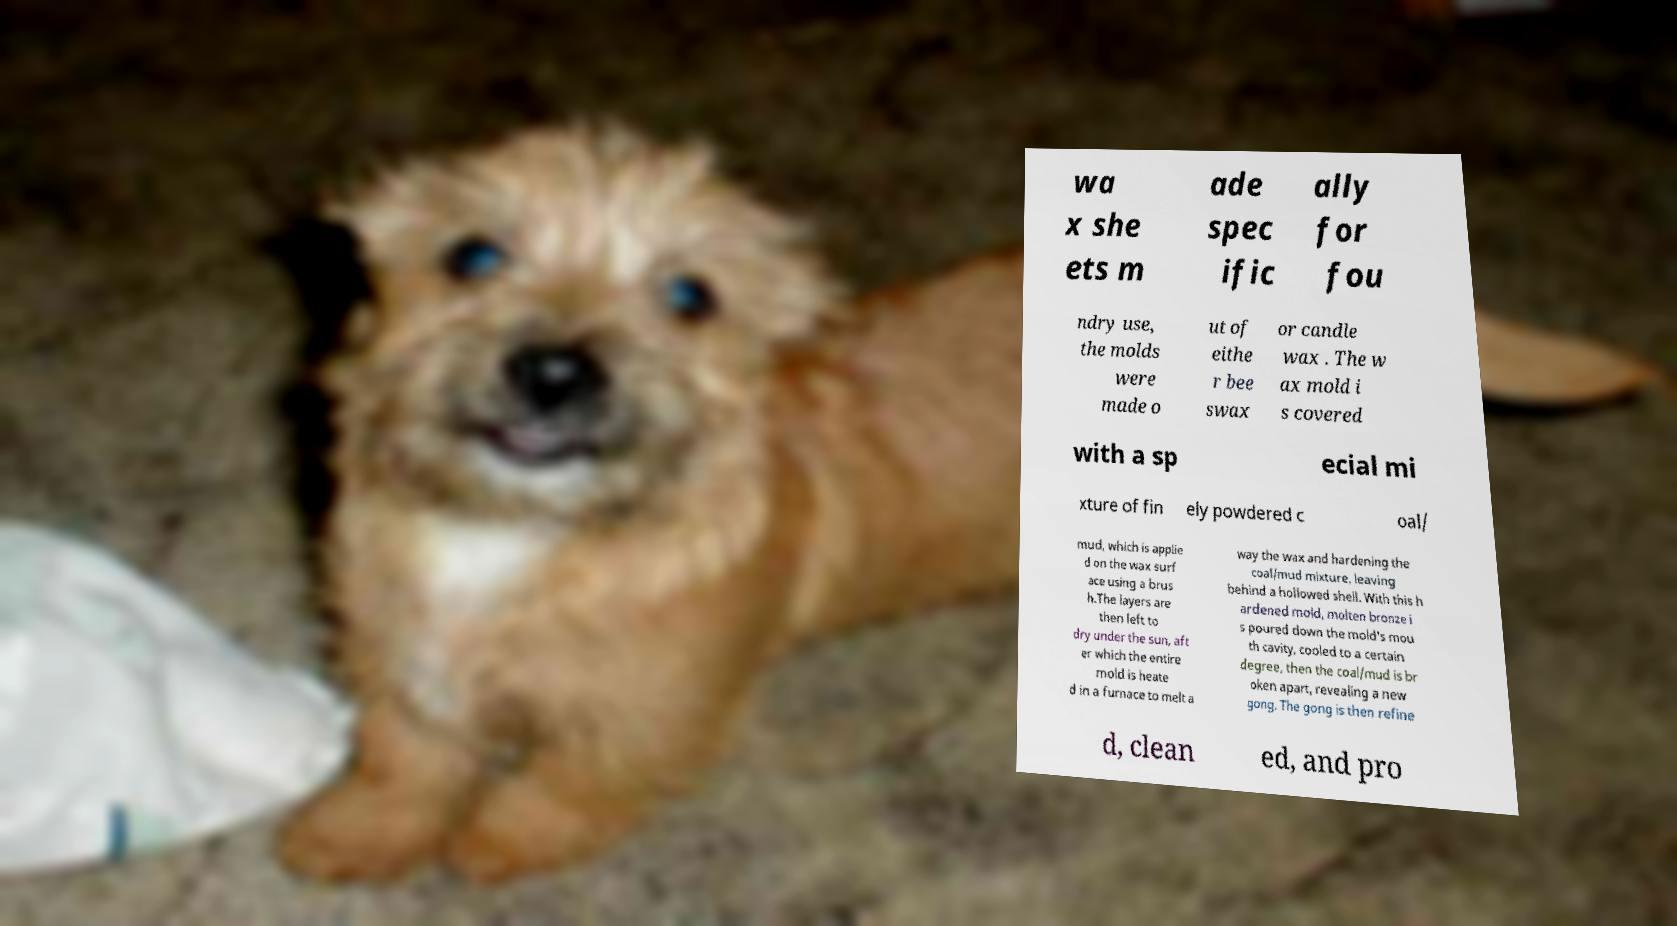Please read and relay the text visible in this image. What does it say? wa x she ets m ade spec ific ally for fou ndry use, the molds were made o ut of eithe r bee swax or candle wax . The w ax mold i s covered with a sp ecial mi xture of fin ely powdered c oal/ mud, which is applie d on the wax surf ace using a brus h.The layers are then left to dry under the sun, aft er which the entire mold is heate d in a furnace to melt a way the wax and hardening the coal/mud mixture, leaving behind a hollowed shell. With this h ardened mold, molten bronze i s poured down the mold's mou th cavity, cooled to a certain degree, then the coal/mud is br oken apart, revealing a new gong. The gong is then refine d, clean ed, and pro 